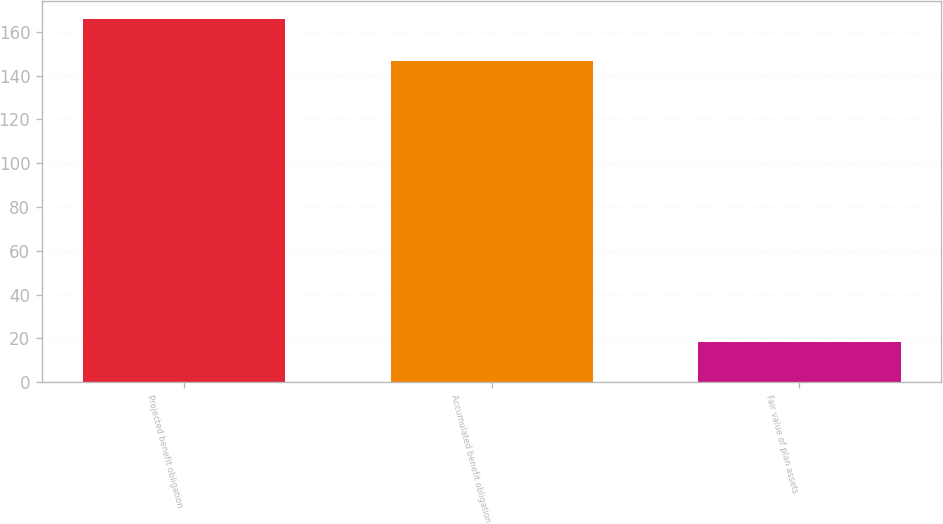Convert chart. <chart><loc_0><loc_0><loc_500><loc_500><bar_chart><fcel>Projected benefit obligation<fcel>Accumulated benefit obligation<fcel>Fair value of plan assets<nl><fcel>165.7<fcel>146.8<fcel>18.3<nl></chart> 